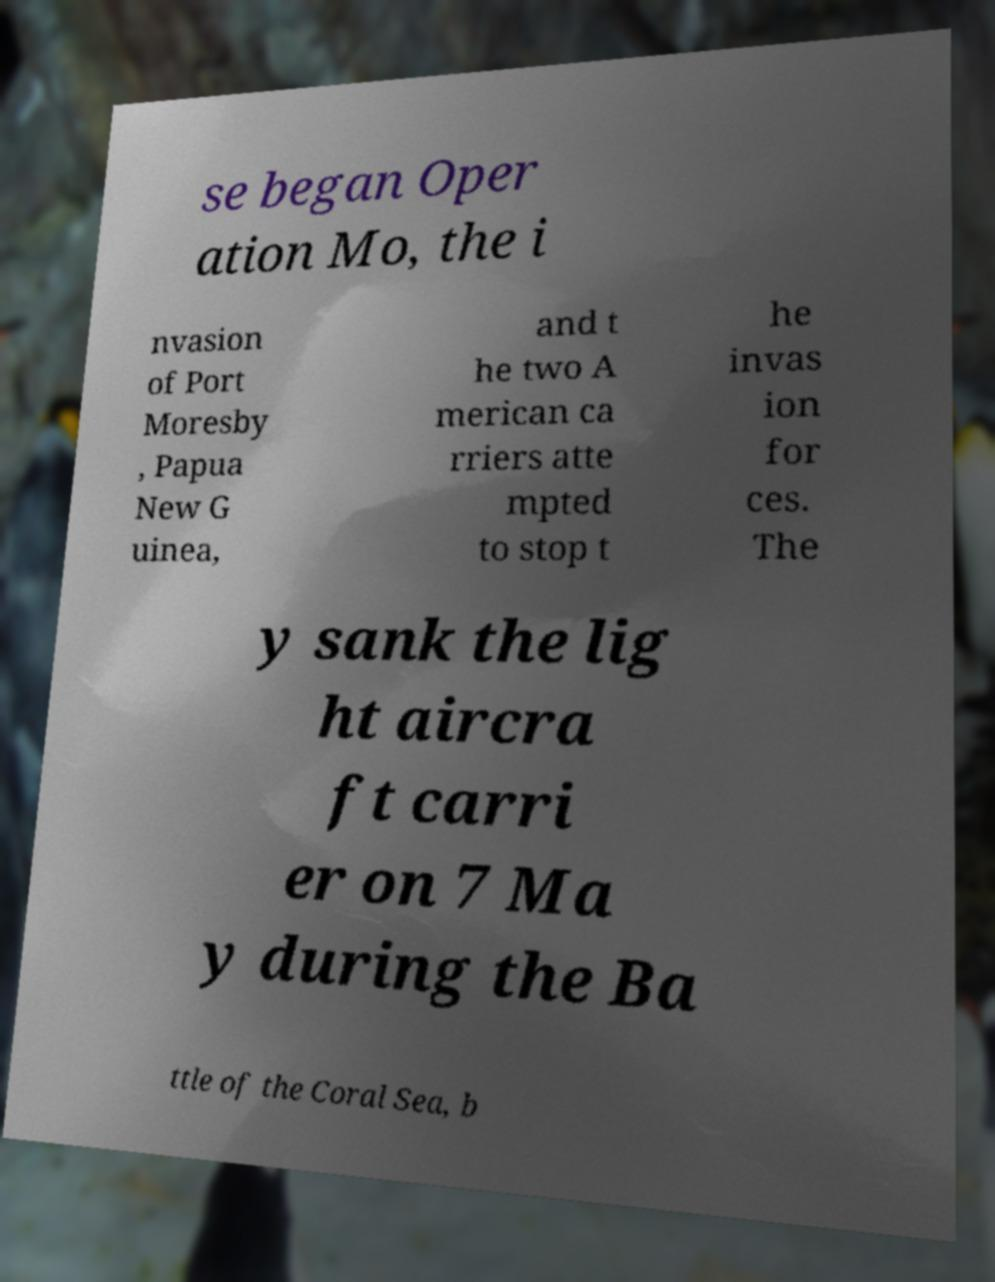I need the written content from this picture converted into text. Can you do that? se began Oper ation Mo, the i nvasion of Port Moresby , Papua New G uinea, and t he two A merican ca rriers atte mpted to stop t he invas ion for ces. The y sank the lig ht aircra ft carri er on 7 Ma y during the Ba ttle of the Coral Sea, b 